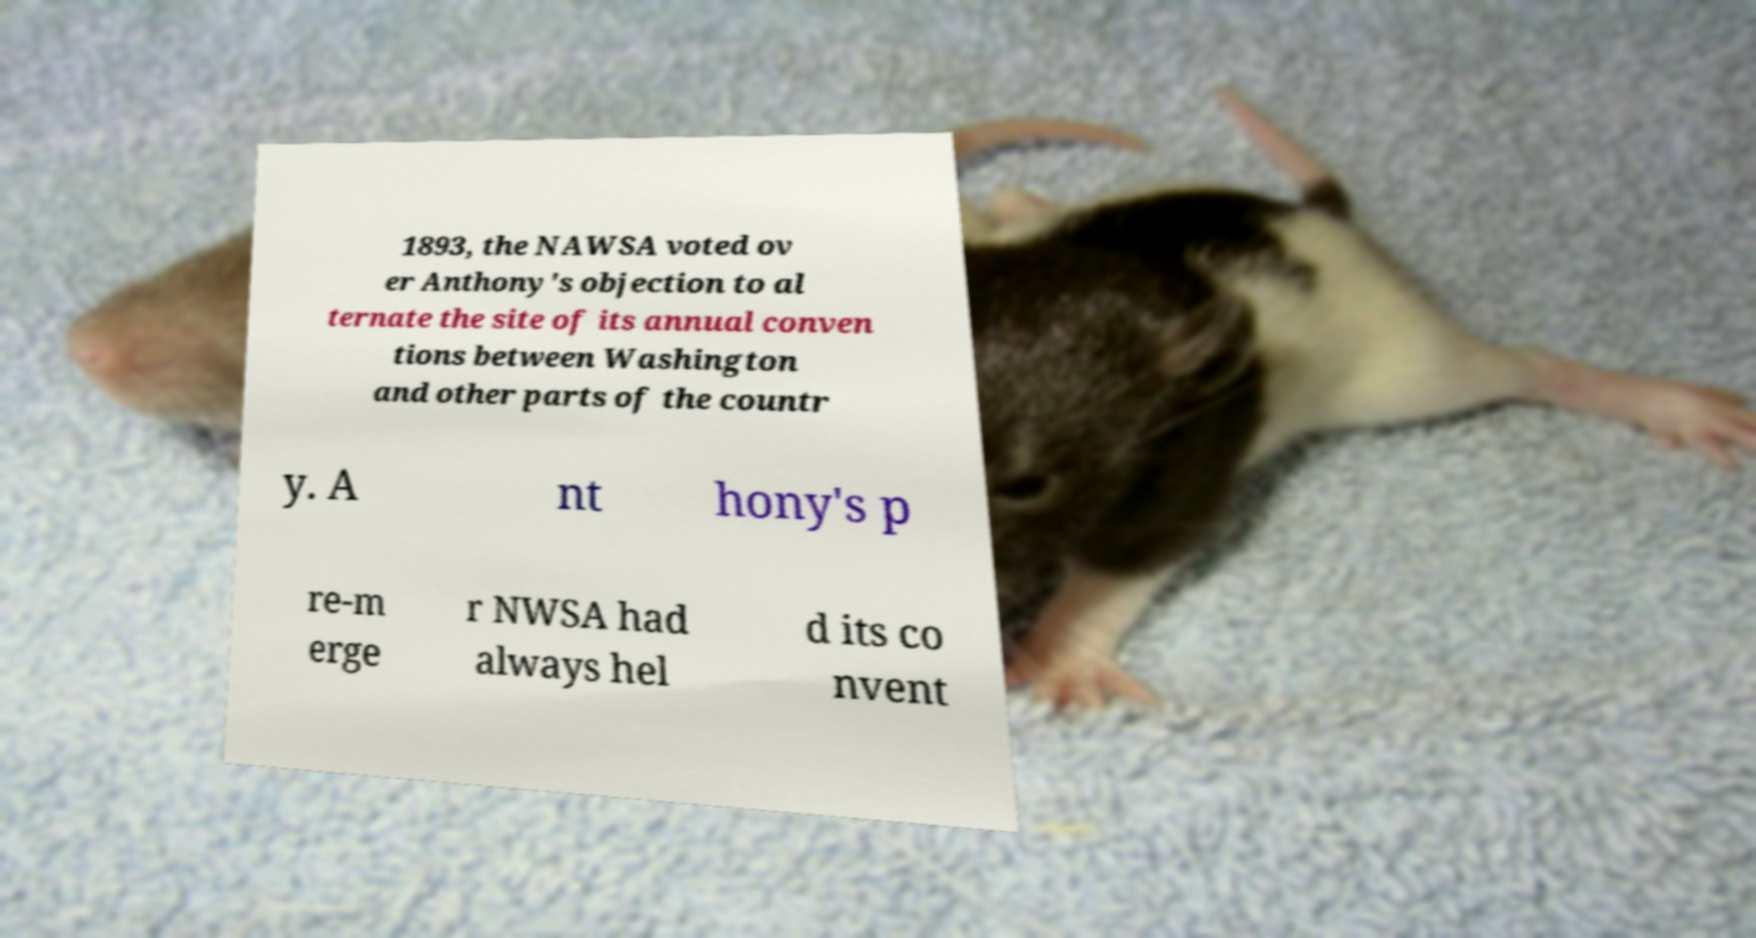There's text embedded in this image that I need extracted. Can you transcribe it verbatim? 1893, the NAWSA voted ov er Anthony's objection to al ternate the site of its annual conven tions between Washington and other parts of the countr y. A nt hony's p re-m erge r NWSA had always hel d its co nvent 